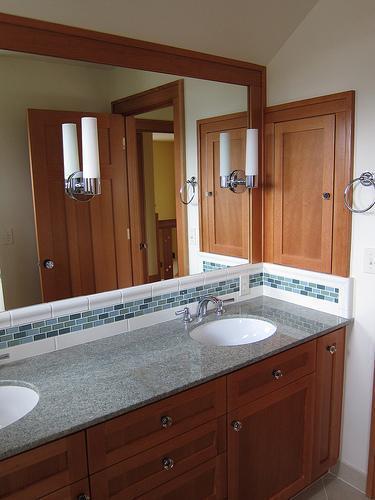How many glass knobs are there?
Give a very brief answer. 7. 